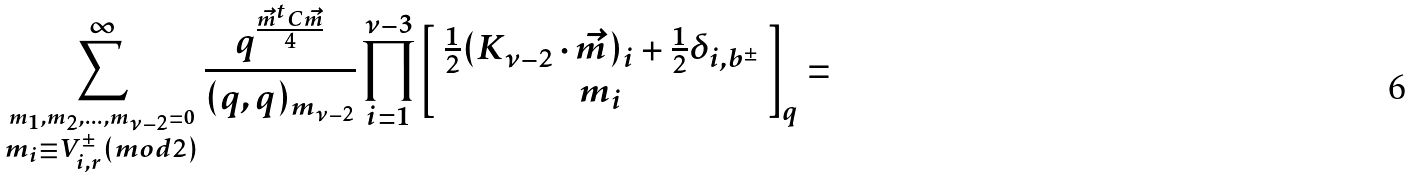<formula> <loc_0><loc_0><loc_500><loc_500>\sum ^ { \infty } _ { \stackrel { m _ { 1 } , m _ { 2 } , \dots , m _ { \nu - 2 } = 0 } { m _ { i } \equiv V _ { i , r } ^ { \pm } ( m o d 2 ) } } \frac { q ^ { \frac { \vec { m } ^ { t } C \vec { m } } { 4 } } } { ( q , q ) _ { m _ { \nu - 2 } } } \prod _ { i = 1 } ^ { \nu - 3 } \left [ \begin{array} { c } \frac { 1 } { 2 } ( K _ { \nu - 2 } \cdot \vec { m } ) _ { i } + \frac { 1 } { 2 } \delta _ { i , b ^ { \pm } } \\ m _ { i } \end{array} \right ] _ { q } =</formula> 